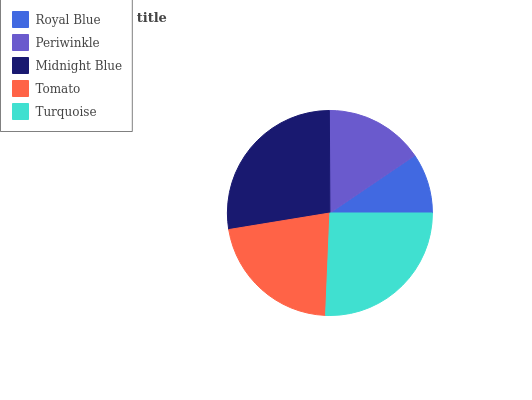Is Royal Blue the minimum?
Answer yes or no. Yes. Is Midnight Blue the maximum?
Answer yes or no. Yes. Is Periwinkle the minimum?
Answer yes or no. No. Is Periwinkle the maximum?
Answer yes or no. No. Is Periwinkle greater than Royal Blue?
Answer yes or no. Yes. Is Royal Blue less than Periwinkle?
Answer yes or no. Yes. Is Royal Blue greater than Periwinkle?
Answer yes or no. No. Is Periwinkle less than Royal Blue?
Answer yes or no. No. Is Tomato the high median?
Answer yes or no. Yes. Is Tomato the low median?
Answer yes or no. Yes. Is Turquoise the high median?
Answer yes or no. No. Is Periwinkle the low median?
Answer yes or no. No. 